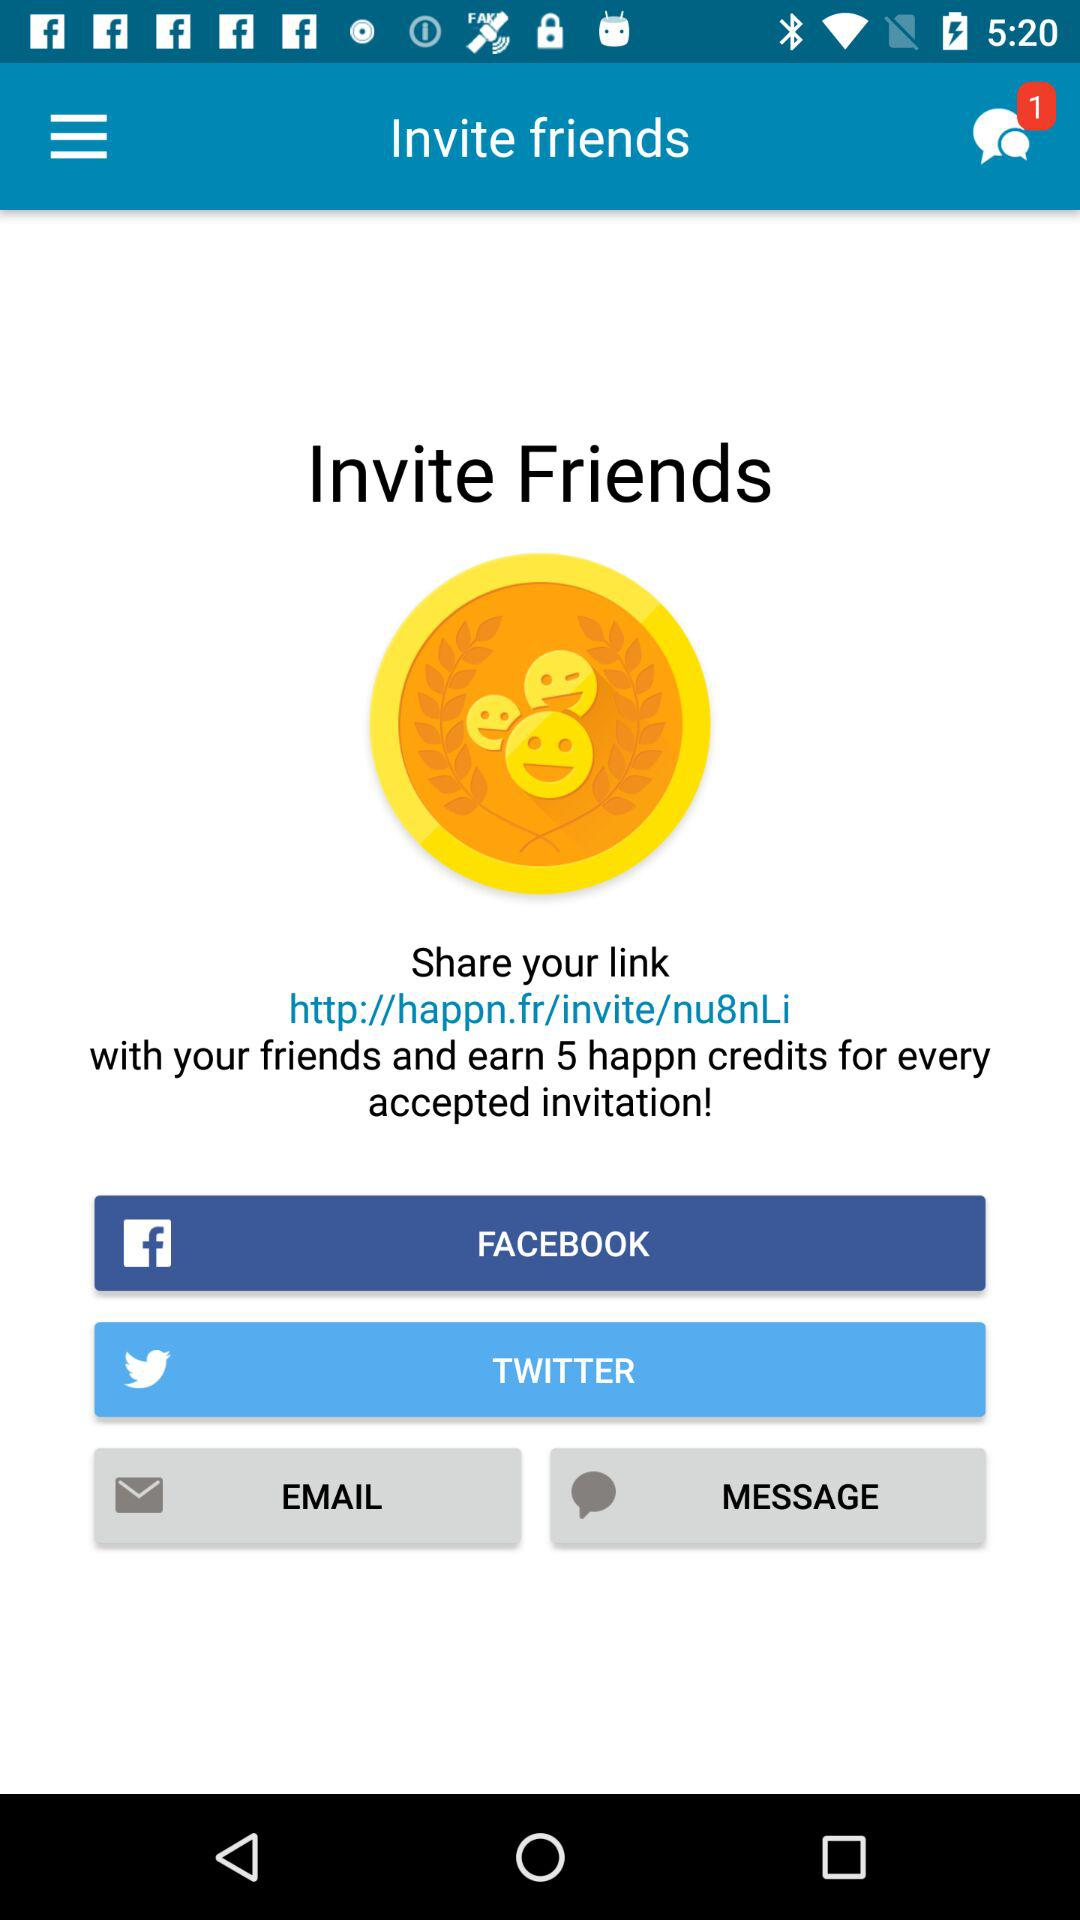What are the sharing options? The sharing options are "FACEBOOK", "TWITTER", "EMAIL" and "MESSAGE". 